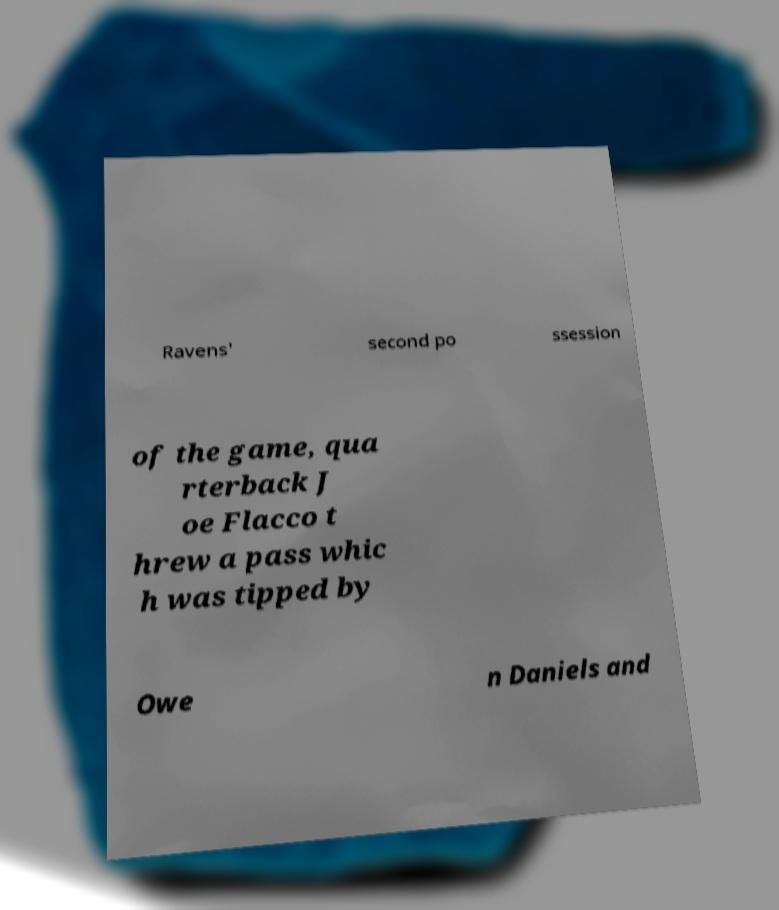Can you read and provide the text displayed in the image?This photo seems to have some interesting text. Can you extract and type it out for me? Ravens' second po ssession of the game, qua rterback J oe Flacco t hrew a pass whic h was tipped by Owe n Daniels and 